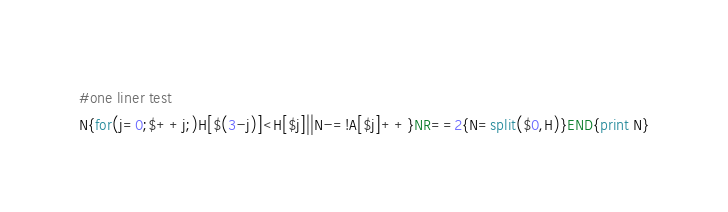Convert code to text. <code><loc_0><loc_0><loc_500><loc_500><_Awk_>#one liner test
N{for(j=0;$++j;)H[$(3-j)]<H[$j]||N-=!A[$j]++}NR==2{N=split($0,H)}END{print N}</code> 